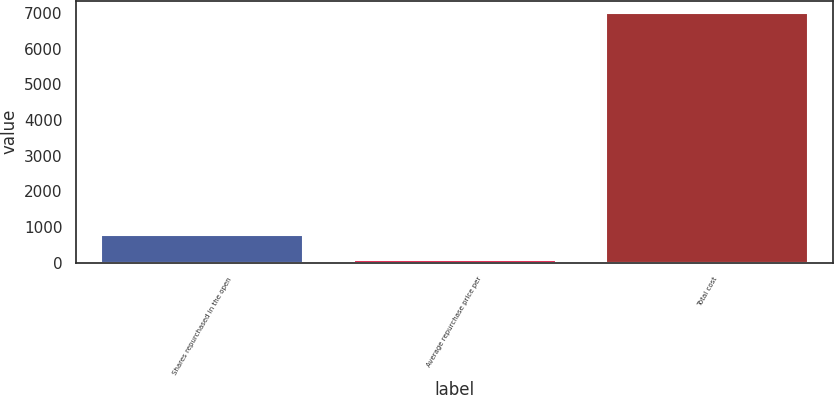<chart> <loc_0><loc_0><loc_500><loc_500><bar_chart><fcel>Shares repurchased in the open<fcel>Average repurchase price per<fcel>Total cost<nl><fcel>768.04<fcel>77.05<fcel>6987<nl></chart> 